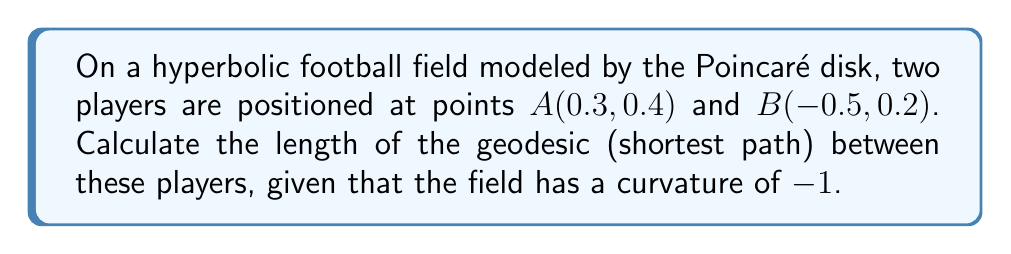Can you solve this math problem? Let's approach this step-by-step:

1) In the Poincaré disk model, the distance between two points is given by the formula:

   $$d = \text{arcosh}\left(1 + \frac{2|z_1 - z_2|^2}{(1-|z_1|^2)(1-|z_2|^2)}\right)$$

   where $z_1$ and $z_2$ are complex numbers representing the two points.

2) Convert the given coordinates to complex numbers:
   $z_1 = 0.3 + 0.4i$
   $z_2 = -0.5 + 0.2i$

3) Calculate $|z_1 - z_2|^2$:
   $$|z_1 - z_2|^2 = (0.3 - (-0.5))^2 + (0.4 - 0.2)^2 = 0.8^2 + 0.2^2 = 0.68$$

4) Calculate $|z_1|^2$ and $|z_2|^2$:
   $$|z_1|^2 = 0.3^2 + 0.4^2 = 0.25$$
   $$|z_2|^2 = (-0.5)^2 + 0.2^2 = 0.29$$

5) Substitute these values into the distance formula:

   $$d = \text{arcosh}\left(1 + \frac{2(0.68)}{(1-0.25)(1-0.29)}\right)$$

6) Simplify:
   $$d = \text{arcosh}\left(1 + \frac{1.36}{0.75 \cdot 0.71}\right) = \text{arcosh}\left(1 + \frac{1.36}{0.5325}\right) = \text{arcosh}(3.5533)$$

7) Calculate the final result:
   $$d \approx 1.9924$$

This value represents the length of the geodesic in the hyperbolic plane with curvature -1.
Answer: $1.9924$ 